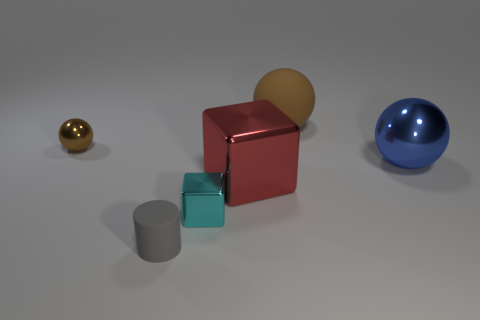Subtract all small metallic balls. How many balls are left? 2 Subtract all blue spheres. How many spheres are left? 2 Subtract 0 gray balls. How many objects are left? 6 Subtract all cylinders. How many objects are left? 5 Subtract 2 blocks. How many blocks are left? 0 Subtract all green blocks. Subtract all cyan cylinders. How many blocks are left? 2 Subtract all blue blocks. How many brown balls are left? 2 Subtract all cyan metallic cubes. Subtract all big blue metallic spheres. How many objects are left? 4 Add 2 tiny objects. How many tiny objects are left? 5 Add 5 brown balls. How many brown balls exist? 7 